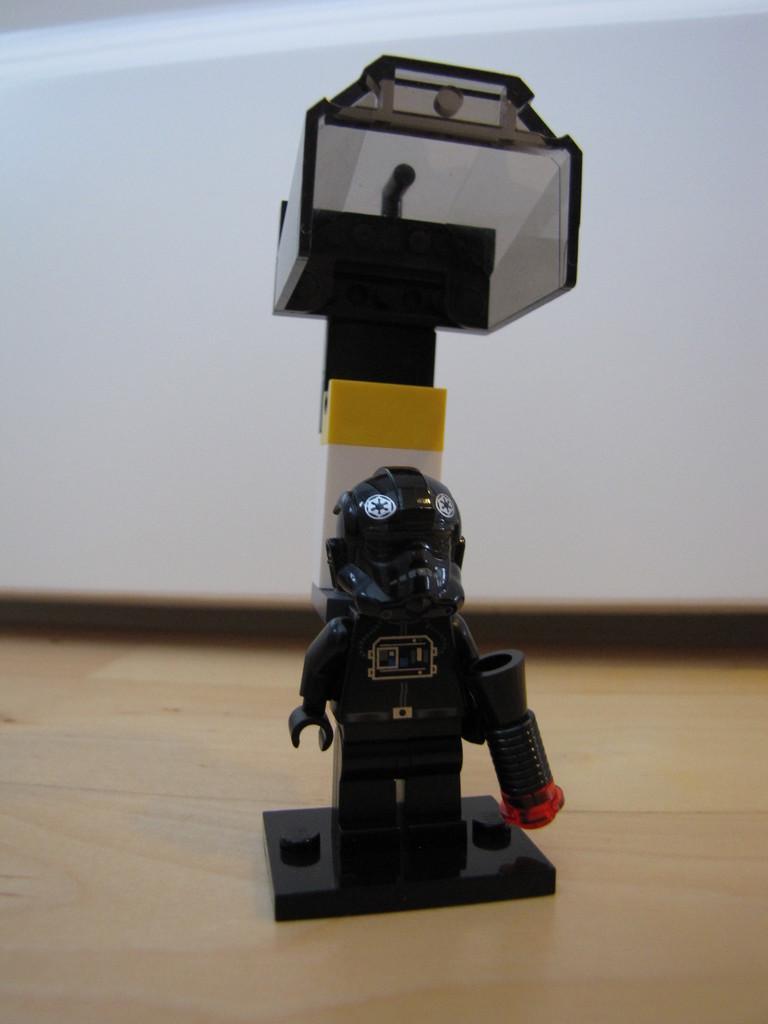Please provide a concise description of this image. In this picture there is a toy. At the bottom it looks like a table. At the back it looks like an object. 